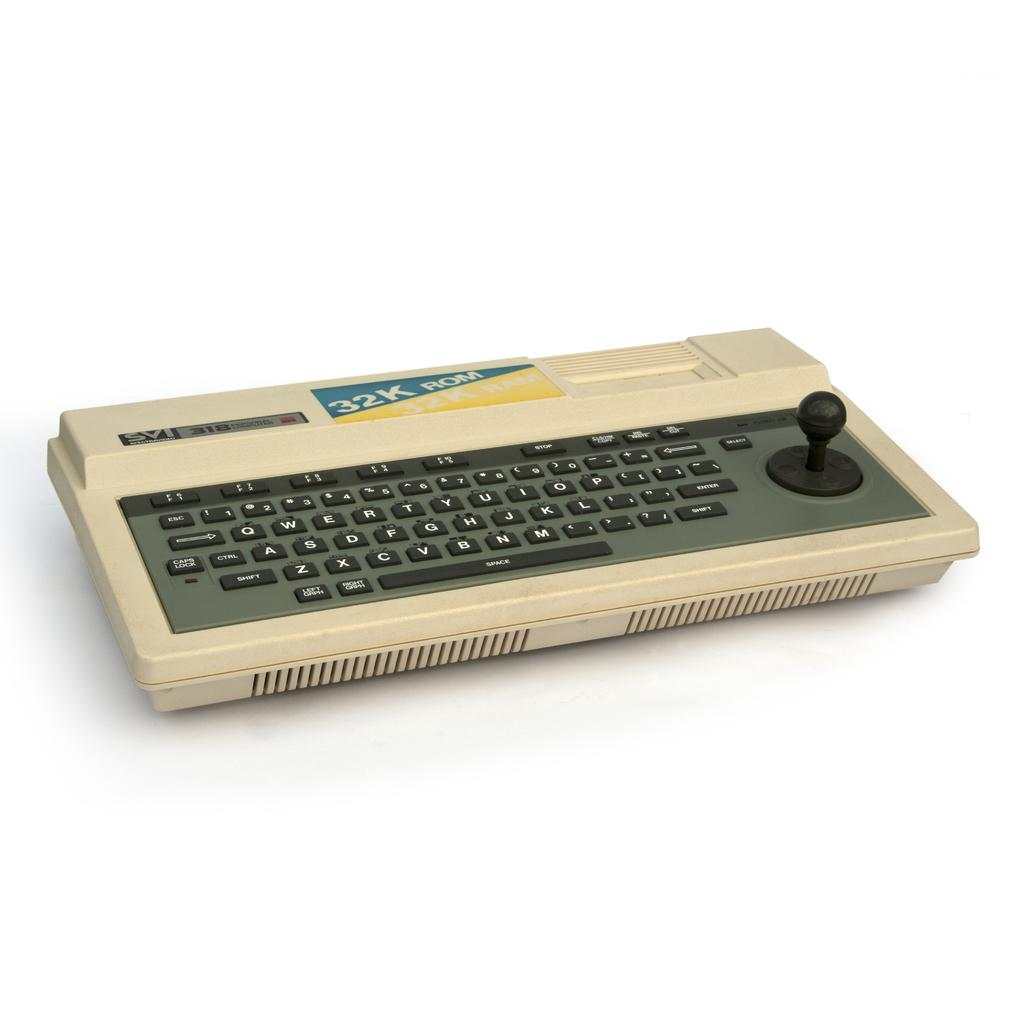Provide a one-sentence caption for the provided image. A white keyboard with the letters and word written on the top 32K Rom. 